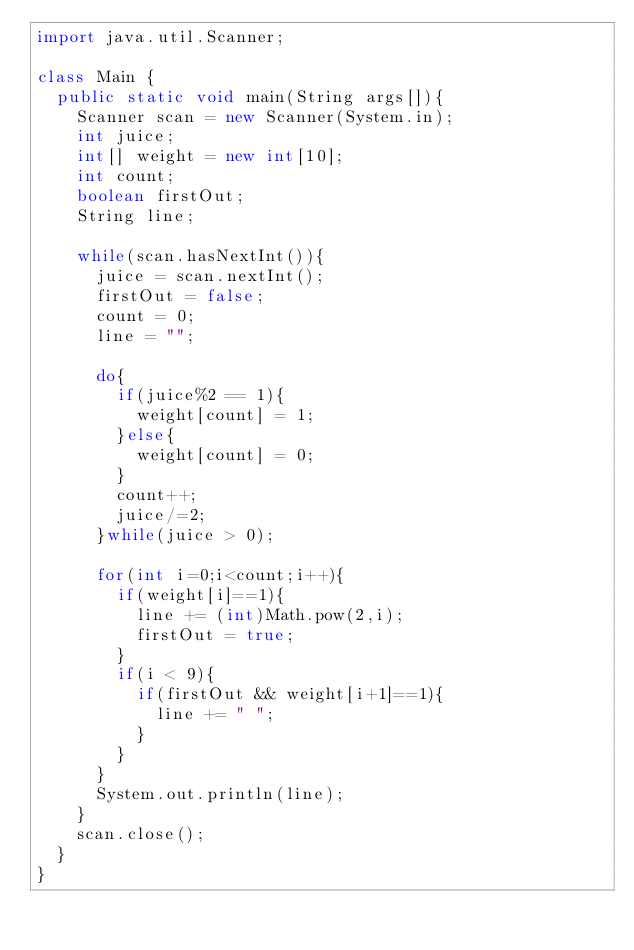Convert code to text. <code><loc_0><loc_0><loc_500><loc_500><_Java_>import java.util.Scanner;

class Main {
	public static void main(String args[]){
		Scanner scan = new Scanner(System.in);
		int juice;
		int[] weight = new int[10];
		int count;
		boolean firstOut;
		String line;
		
		while(scan.hasNextInt()){
			juice = scan.nextInt();
			firstOut = false;
			count = 0;
			line = "";
			
			do{
				if(juice%2 == 1){
					weight[count] = 1;
				}else{
					weight[count] = 0;
				}
				count++;
				juice/=2;
			}while(juice > 0);
			
			for(int i=0;i<count;i++){
				if(weight[i]==1){
					line += (int)Math.pow(2,i);
					firstOut = true;
				}
				if(i < 9){
					if(firstOut && weight[i+1]==1){
						line += " ";
					}
				}
			}
			System.out.println(line);
		}
		scan.close();
	}
}</code> 